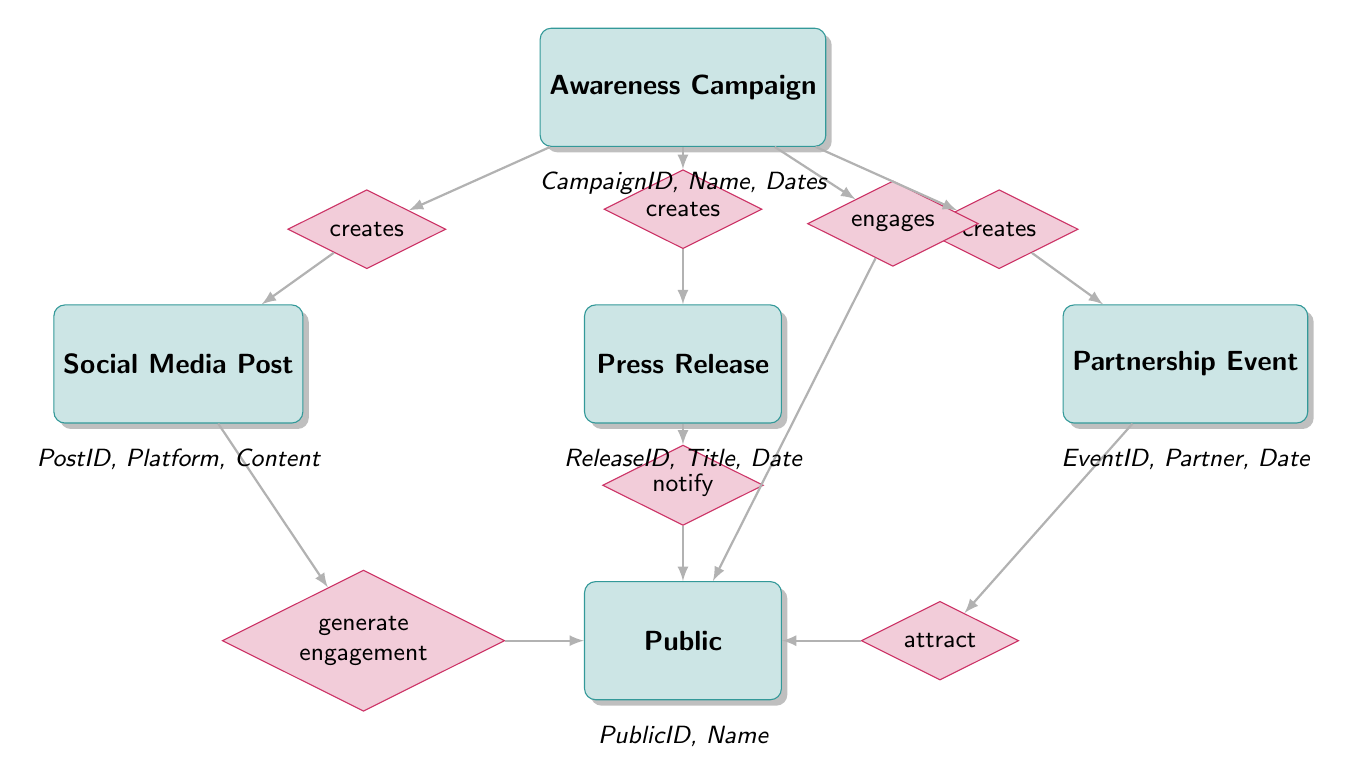What entity is responsible for creating Social Media Posts? The diagram shows that the Awareness Campaign entity has a relationship that indicates it creates Social Media Posts.
Answer: Awareness Campaign How many entities are involved in the diagram? By counting the distinct entities depicted in the diagram, including Awareness Campaign, Social Media Post, Press Release, Partnership Event, and Public, there are a total of five entities.
Answer: 5 What relationship indicates that the Public is engaged by multiple elements? The diagram illustrates that the Public is engaged by Social Media Posts, Press Releases, and Partnership Events, indicated by the relationship labeled "engaged_by."
Answer: engaged_by What is the relationship between Partnership Event and Awareness Campaign? The diagram establishes a relationship labeled "creates" connecting Partnership Event back to the Awareness Campaign entity, indicating that Partnership Events are created as part of the campaign efforts.
Answer: creates Which entity has the attribute "Content"? The diagram shows that the Social Media Post entity includes the attribute "Content," which specifies the material posted on social media platforms.
Answer: Social Media Post What type of events can attract the Public according to the diagram? The Partnership Event entity is shown to have a relationship labeled "attract," which indicates these events draw the interest of the Public.
Answer: Partnership Event What is the relationship between Press Release and Public? The diagram presents a relationship labeled "notify" connecting the Press Release entity to the Public, indicating that Press Releases serve as notifications to the Public.
Answer: notify Which entity generates engagement from the Public? The Social Media Post entity has a relationship labeled "generate engagement," showing that posts on social media are designed to engage the Public.
Answer: Social Media Post How is the Awareness Campaign linked to the Public? The diagram specifies that the Awareness Campaign "engages" the Public, establishing a direct line of interaction between the campaign and the audience.
Answer: engages 